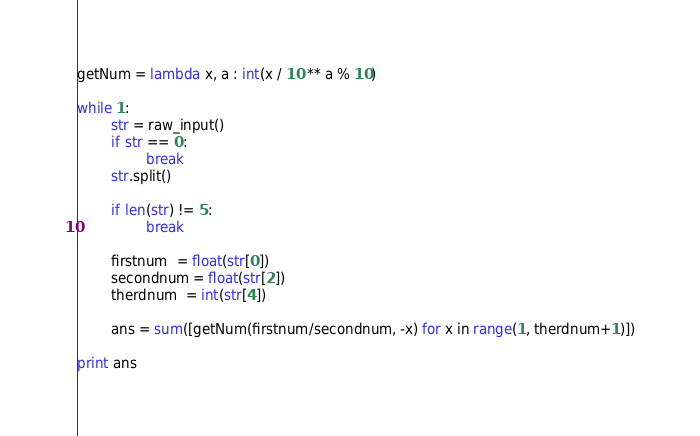<code> <loc_0><loc_0><loc_500><loc_500><_Python_>getNum = lambda x, a : int(x / 10 ** a % 10)

while 1:
        str = raw_input()
        if str == 0:
                break
        str.split()

        if len(str) != 5:
                break

        firstnum  = float(str[0])
        secondnum = float(str[2])
        therdnum  = int(str[4])

        ans = sum([getNum(firstnum/secondnum, -x) for x in range(1, therdnum+1)])

print ans</code> 